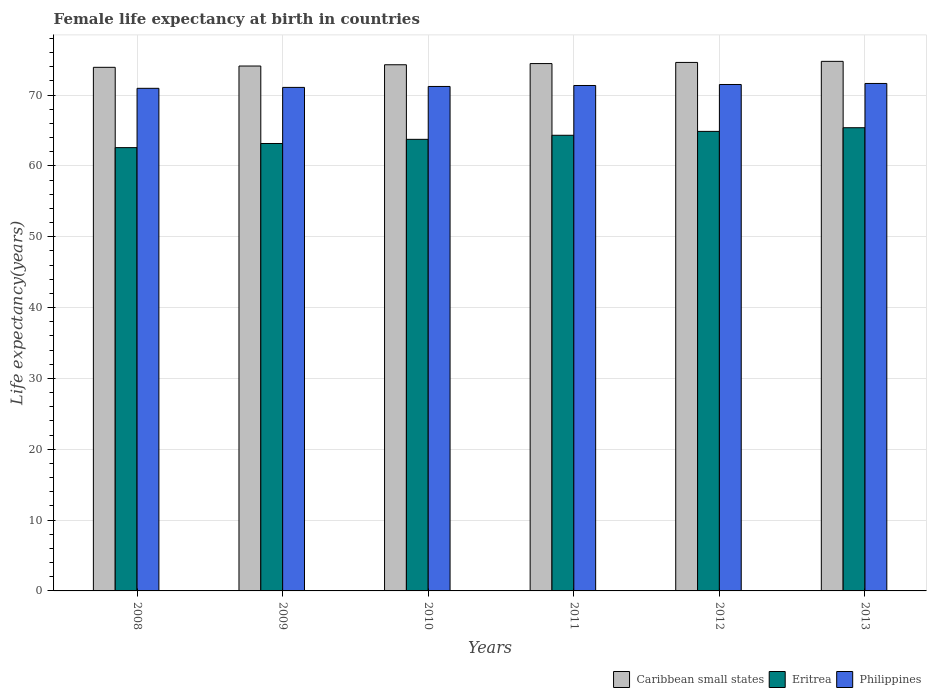How many groups of bars are there?
Your response must be concise. 6. Are the number of bars per tick equal to the number of legend labels?
Your response must be concise. Yes. What is the label of the 1st group of bars from the left?
Your answer should be very brief. 2008. In how many cases, is the number of bars for a given year not equal to the number of legend labels?
Offer a very short reply. 0. What is the female life expectancy at birth in Philippines in 2012?
Give a very brief answer. 71.49. Across all years, what is the maximum female life expectancy at birth in Eritrea?
Offer a very short reply. 65.39. Across all years, what is the minimum female life expectancy at birth in Eritrea?
Give a very brief answer. 62.58. In which year was the female life expectancy at birth in Caribbean small states maximum?
Provide a short and direct response. 2013. What is the total female life expectancy at birth in Philippines in the graph?
Ensure brevity in your answer.  427.72. What is the difference between the female life expectancy at birth in Philippines in 2010 and that in 2013?
Keep it short and to the point. -0.42. What is the difference between the female life expectancy at birth in Philippines in 2010 and the female life expectancy at birth in Eritrea in 2012?
Your response must be concise. 6.34. What is the average female life expectancy at birth in Philippines per year?
Make the answer very short. 71.29. In the year 2010, what is the difference between the female life expectancy at birth in Philippines and female life expectancy at birth in Caribbean small states?
Ensure brevity in your answer.  -3.06. What is the ratio of the female life expectancy at birth in Eritrea in 2012 to that in 2013?
Keep it short and to the point. 0.99. What is the difference between the highest and the second highest female life expectancy at birth in Caribbean small states?
Your answer should be compact. 0.15. What is the difference between the highest and the lowest female life expectancy at birth in Philippines?
Keep it short and to the point. 0.69. Is the sum of the female life expectancy at birth in Caribbean small states in 2009 and 2012 greater than the maximum female life expectancy at birth in Philippines across all years?
Make the answer very short. Yes. What does the 1st bar from the left in 2013 represents?
Provide a succinct answer. Caribbean small states. What does the 2nd bar from the right in 2012 represents?
Your answer should be very brief. Eritrea. What is the difference between two consecutive major ticks on the Y-axis?
Keep it short and to the point. 10. Does the graph contain any zero values?
Make the answer very short. No. Does the graph contain grids?
Your response must be concise. Yes. How many legend labels are there?
Give a very brief answer. 3. What is the title of the graph?
Give a very brief answer. Female life expectancy at birth in countries. Does "St. Vincent and the Grenadines" appear as one of the legend labels in the graph?
Your answer should be compact. No. What is the label or title of the Y-axis?
Offer a very short reply. Life expectancy(years). What is the Life expectancy(years) in Caribbean small states in 2008?
Provide a short and direct response. 73.91. What is the Life expectancy(years) in Eritrea in 2008?
Offer a terse response. 62.58. What is the Life expectancy(years) in Philippines in 2008?
Provide a short and direct response. 70.95. What is the Life expectancy(years) in Caribbean small states in 2009?
Ensure brevity in your answer.  74.1. What is the Life expectancy(years) in Eritrea in 2009?
Ensure brevity in your answer.  63.16. What is the Life expectancy(years) of Philippines in 2009?
Offer a very short reply. 71.08. What is the Life expectancy(years) in Caribbean small states in 2010?
Your answer should be compact. 74.28. What is the Life expectancy(years) of Eritrea in 2010?
Provide a short and direct response. 63.75. What is the Life expectancy(years) in Philippines in 2010?
Your response must be concise. 71.21. What is the Life expectancy(years) of Caribbean small states in 2011?
Make the answer very short. 74.44. What is the Life expectancy(years) of Eritrea in 2011?
Your response must be concise. 64.32. What is the Life expectancy(years) in Philippines in 2011?
Provide a succinct answer. 71.35. What is the Life expectancy(years) in Caribbean small states in 2012?
Keep it short and to the point. 74.6. What is the Life expectancy(years) in Eritrea in 2012?
Your answer should be very brief. 64.87. What is the Life expectancy(years) of Philippines in 2012?
Your answer should be compact. 71.49. What is the Life expectancy(years) in Caribbean small states in 2013?
Your answer should be compact. 74.76. What is the Life expectancy(years) of Eritrea in 2013?
Provide a succinct answer. 65.39. What is the Life expectancy(years) of Philippines in 2013?
Your answer should be very brief. 71.64. Across all years, what is the maximum Life expectancy(years) of Caribbean small states?
Your answer should be very brief. 74.76. Across all years, what is the maximum Life expectancy(years) of Eritrea?
Your answer should be compact. 65.39. Across all years, what is the maximum Life expectancy(years) in Philippines?
Ensure brevity in your answer.  71.64. Across all years, what is the minimum Life expectancy(years) in Caribbean small states?
Offer a very short reply. 73.91. Across all years, what is the minimum Life expectancy(years) in Eritrea?
Your answer should be compact. 62.58. Across all years, what is the minimum Life expectancy(years) of Philippines?
Keep it short and to the point. 70.95. What is the total Life expectancy(years) in Caribbean small states in the graph?
Offer a very short reply. 446.1. What is the total Life expectancy(years) of Eritrea in the graph?
Your answer should be compact. 384.07. What is the total Life expectancy(years) in Philippines in the graph?
Ensure brevity in your answer.  427.72. What is the difference between the Life expectancy(years) in Caribbean small states in 2008 and that in 2009?
Your response must be concise. -0.18. What is the difference between the Life expectancy(years) of Eritrea in 2008 and that in 2009?
Keep it short and to the point. -0.58. What is the difference between the Life expectancy(years) in Philippines in 2008 and that in 2009?
Your answer should be compact. -0.13. What is the difference between the Life expectancy(years) of Caribbean small states in 2008 and that in 2010?
Provide a short and direct response. -0.36. What is the difference between the Life expectancy(years) in Eritrea in 2008 and that in 2010?
Give a very brief answer. -1.17. What is the difference between the Life expectancy(years) in Philippines in 2008 and that in 2010?
Make the answer very short. -0.26. What is the difference between the Life expectancy(years) of Caribbean small states in 2008 and that in 2011?
Keep it short and to the point. -0.53. What is the difference between the Life expectancy(years) in Eritrea in 2008 and that in 2011?
Offer a terse response. -1.74. What is the difference between the Life expectancy(years) in Philippines in 2008 and that in 2011?
Ensure brevity in your answer.  -0.4. What is the difference between the Life expectancy(years) of Caribbean small states in 2008 and that in 2012?
Offer a very short reply. -0.69. What is the difference between the Life expectancy(years) in Eritrea in 2008 and that in 2012?
Keep it short and to the point. -2.29. What is the difference between the Life expectancy(years) of Philippines in 2008 and that in 2012?
Your answer should be very brief. -0.54. What is the difference between the Life expectancy(years) of Caribbean small states in 2008 and that in 2013?
Keep it short and to the point. -0.84. What is the difference between the Life expectancy(years) of Eritrea in 2008 and that in 2013?
Offer a very short reply. -2.81. What is the difference between the Life expectancy(years) in Philippines in 2008 and that in 2013?
Provide a short and direct response. -0.69. What is the difference between the Life expectancy(years) of Caribbean small states in 2009 and that in 2010?
Keep it short and to the point. -0.18. What is the difference between the Life expectancy(years) of Eritrea in 2009 and that in 2010?
Your answer should be very brief. -0.59. What is the difference between the Life expectancy(years) in Philippines in 2009 and that in 2010?
Ensure brevity in your answer.  -0.13. What is the difference between the Life expectancy(years) of Caribbean small states in 2009 and that in 2011?
Keep it short and to the point. -0.35. What is the difference between the Life expectancy(years) in Eritrea in 2009 and that in 2011?
Make the answer very short. -1.16. What is the difference between the Life expectancy(years) of Philippines in 2009 and that in 2011?
Your answer should be very brief. -0.27. What is the difference between the Life expectancy(years) in Caribbean small states in 2009 and that in 2012?
Provide a succinct answer. -0.51. What is the difference between the Life expectancy(years) of Eritrea in 2009 and that in 2012?
Offer a very short reply. -1.71. What is the difference between the Life expectancy(years) of Philippines in 2009 and that in 2012?
Your answer should be compact. -0.41. What is the difference between the Life expectancy(years) of Caribbean small states in 2009 and that in 2013?
Give a very brief answer. -0.66. What is the difference between the Life expectancy(years) in Eritrea in 2009 and that in 2013?
Keep it short and to the point. -2.23. What is the difference between the Life expectancy(years) in Philippines in 2009 and that in 2013?
Ensure brevity in your answer.  -0.56. What is the difference between the Life expectancy(years) in Caribbean small states in 2010 and that in 2011?
Your answer should be compact. -0.17. What is the difference between the Life expectancy(years) of Eritrea in 2010 and that in 2011?
Your response must be concise. -0.57. What is the difference between the Life expectancy(years) of Philippines in 2010 and that in 2011?
Provide a succinct answer. -0.14. What is the difference between the Life expectancy(years) of Caribbean small states in 2010 and that in 2012?
Offer a very short reply. -0.33. What is the difference between the Life expectancy(years) in Eritrea in 2010 and that in 2012?
Provide a short and direct response. -1.12. What is the difference between the Life expectancy(years) of Philippines in 2010 and that in 2012?
Your response must be concise. -0.28. What is the difference between the Life expectancy(years) in Caribbean small states in 2010 and that in 2013?
Give a very brief answer. -0.48. What is the difference between the Life expectancy(years) in Eritrea in 2010 and that in 2013?
Your answer should be very brief. -1.64. What is the difference between the Life expectancy(years) in Philippines in 2010 and that in 2013?
Keep it short and to the point. -0.42. What is the difference between the Life expectancy(years) in Caribbean small states in 2011 and that in 2012?
Ensure brevity in your answer.  -0.16. What is the difference between the Life expectancy(years) in Eritrea in 2011 and that in 2012?
Your response must be concise. -0.55. What is the difference between the Life expectancy(years) in Philippines in 2011 and that in 2012?
Provide a succinct answer. -0.14. What is the difference between the Life expectancy(years) of Caribbean small states in 2011 and that in 2013?
Provide a short and direct response. -0.31. What is the difference between the Life expectancy(years) in Eritrea in 2011 and that in 2013?
Your response must be concise. -1.07. What is the difference between the Life expectancy(years) of Philippines in 2011 and that in 2013?
Your answer should be compact. -0.29. What is the difference between the Life expectancy(years) in Caribbean small states in 2012 and that in 2013?
Offer a very short reply. -0.15. What is the difference between the Life expectancy(years) of Eritrea in 2012 and that in 2013?
Provide a short and direct response. -0.52. What is the difference between the Life expectancy(years) of Philippines in 2012 and that in 2013?
Ensure brevity in your answer.  -0.15. What is the difference between the Life expectancy(years) in Caribbean small states in 2008 and the Life expectancy(years) in Eritrea in 2009?
Make the answer very short. 10.75. What is the difference between the Life expectancy(years) of Caribbean small states in 2008 and the Life expectancy(years) of Philippines in 2009?
Offer a terse response. 2.83. What is the difference between the Life expectancy(years) in Eritrea in 2008 and the Life expectancy(years) in Philippines in 2009?
Offer a terse response. -8.5. What is the difference between the Life expectancy(years) in Caribbean small states in 2008 and the Life expectancy(years) in Eritrea in 2010?
Provide a succinct answer. 10.17. What is the difference between the Life expectancy(years) of Caribbean small states in 2008 and the Life expectancy(years) of Philippines in 2010?
Ensure brevity in your answer.  2.7. What is the difference between the Life expectancy(years) in Eritrea in 2008 and the Life expectancy(years) in Philippines in 2010?
Offer a very short reply. -8.64. What is the difference between the Life expectancy(years) of Caribbean small states in 2008 and the Life expectancy(years) of Eritrea in 2011?
Provide a succinct answer. 9.59. What is the difference between the Life expectancy(years) of Caribbean small states in 2008 and the Life expectancy(years) of Philippines in 2011?
Make the answer very short. 2.57. What is the difference between the Life expectancy(years) of Eritrea in 2008 and the Life expectancy(years) of Philippines in 2011?
Offer a terse response. -8.77. What is the difference between the Life expectancy(years) of Caribbean small states in 2008 and the Life expectancy(years) of Eritrea in 2012?
Provide a succinct answer. 9.04. What is the difference between the Life expectancy(years) of Caribbean small states in 2008 and the Life expectancy(years) of Philippines in 2012?
Provide a short and direct response. 2.42. What is the difference between the Life expectancy(years) of Eritrea in 2008 and the Life expectancy(years) of Philippines in 2012?
Keep it short and to the point. -8.91. What is the difference between the Life expectancy(years) of Caribbean small states in 2008 and the Life expectancy(years) of Eritrea in 2013?
Offer a very short reply. 8.53. What is the difference between the Life expectancy(years) in Caribbean small states in 2008 and the Life expectancy(years) in Philippines in 2013?
Ensure brevity in your answer.  2.28. What is the difference between the Life expectancy(years) of Eritrea in 2008 and the Life expectancy(years) of Philippines in 2013?
Your answer should be very brief. -9.06. What is the difference between the Life expectancy(years) in Caribbean small states in 2009 and the Life expectancy(years) in Eritrea in 2010?
Your response must be concise. 10.35. What is the difference between the Life expectancy(years) in Caribbean small states in 2009 and the Life expectancy(years) in Philippines in 2010?
Keep it short and to the point. 2.89. What is the difference between the Life expectancy(years) of Eritrea in 2009 and the Life expectancy(years) of Philippines in 2010?
Give a very brief answer. -8.05. What is the difference between the Life expectancy(years) in Caribbean small states in 2009 and the Life expectancy(years) in Eritrea in 2011?
Give a very brief answer. 9.78. What is the difference between the Life expectancy(years) of Caribbean small states in 2009 and the Life expectancy(years) of Philippines in 2011?
Your response must be concise. 2.75. What is the difference between the Life expectancy(years) in Eritrea in 2009 and the Life expectancy(years) in Philippines in 2011?
Your response must be concise. -8.19. What is the difference between the Life expectancy(years) of Caribbean small states in 2009 and the Life expectancy(years) of Eritrea in 2012?
Offer a terse response. 9.23. What is the difference between the Life expectancy(years) of Caribbean small states in 2009 and the Life expectancy(years) of Philippines in 2012?
Provide a short and direct response. 2.61. What is the difference between the Life expectancy(years) in Eritrea in 2009 and the Life expectancy(years) in Philippines in 2012?
Your answer should be compact. -8.33. What is the difference between the Life expectancy(years) of Caribbean small states in 2009 and the Life expectancy(years) of Eritrea in 2013?
Ensure brevity in your answer.  8.71. What is the difference between the Life expectancy(years) of Caribbean small states in 2009 and the Life expectancy(years) of Philippines in 2013?
Offer a very short reply. 2.46. What is the difference between the Life expectancy(years) of Eritrea in 2009 and the Life expectancy(years) of Philippines in 2013?
Provide a short and direct response. -8.47. What is the difference between the Life expectancy(years) in Caribbean small states in 2010 and the Life expectancy(years) in Eritrea in 2011?
Give a very brief answer. 9.95. What is the difference between the Life expectancy(years) of Caribbean small states in 2010 and the Life expectancy(years) of Philippines in 2011?
Offer a terse response. 2.93. What is the difference between the Life expectancy(years) in Caribbean small states in 2010 and the Life expectancy(years) in Eritrea in 2012?
Give a very brief answer. 9.4. What is the difference between the Life expectancy(years) in Caribbean small states in 2010 and the Life expectancy(years) in Philippines in 2012?
Your answer should be compact. 2.79. What is the difference between the Life expectancy(years) of Eritrea in 2010 and the Life expectancy(years) of Philippines in 2012?
Ensure brevity in your answer.  -7.74. What is the difference between the Life expectancy(years) of Caribbean small states in 2010 and the Life expectancy(years) of Eritrea in 2013?
Give a very brief answer. 8.89. What is the difference between the Life expectancy(years) in Caribbean small states in 2010 and the Life expectancy(years) in Philippines in 2013?
Offer a very short reply. 2.64. What is the difference between the Life expectancy(years) in Eritrea in 2010 and the Life expectancy(years) in Philippines in 2013?
Make the answer very short. -7.89. What is the difference between the Life expectancy(years) in Caribbean small states in 2011 and the Life expectancy(years) in Eritrea in 2012?
Offer a terse response. 9.57. What is the difference between the Life expectancy(years) of Caribbean small states in 2011 and the Life expectancy(years) of Philippines in 2012?
Your answer should be compact. 2.96. What is the difference between the Life expectancy(years) of Eritrea in 2011 and the Life expectancy(years) of Philippines in 2012?
Provide a succinct answer. -7.17. What is the difference between the Life expectancy(years) in Caribbean small states in 2011 and the Life expectancy(years) in Eritrea in 2013?
Offer a terse response. 9.06. What is the difference between the Life expectancy(years) in Caribbean small states in 2011 and the Life expectancy(years) in Philippines in 2013?
Provide a succinct answer. 2.81. What is the difference between the Life expectancy(years) of Eritrea in 2011 and the Life expectancy(years) of Philippines in 2013?
Offer a very short reply. -7.31. What is the difference between the Life expectancy(years) of Caribbean small states in 2012 and the Life expectancy(years) of Eritrea in 2013?
Make the answer very short. 9.22. What is the difference between the Life expectancy(years) in Caribbean small states in 2012 and the Life expectancy(years) in Philippines in 2013?
Provide a short and direct response. 2.97. What is the difference between the Life expectancy(years) of Eritrea in 2012 and the Life expectancy(years) of Philippines in 2013?
Your answer should be compact. -6.76. What is the average Life expectancy(years) in Caribbean small states per year?
Offer a very short reply. 74.35. What is the average Life expectancy(years) in Eritrea per year?
Your answer should be compact. 64.01. What is the average Life expectancy(years) of Philippines per year?
Offer a very short reply. 71.29. In the year 2008, what is the difference between the Life expectancy(years) in Caribbean small states and Life expectancy(years) in Eritrea?
Keep it short and to the point. 11.34. In the year 2008, what is the difference between the Life expectancy(years) of Caribbean small states and Life expectancy(years) of Philippines?
Your response must be concise. 2.96. In the year 2008, what is the difference between the Life expectancy(years) of Eritrea and Life expectancy(years) of Philippines?
Make the answer very short. -8.37. In the year 2009, what is the difference between the Life expectancy(years) of Caribbean small states and Life expectancy(years) of Eritrea?
Offer a terse response. 10.94. In the year 2009, what is the difference between the Life expectancy(years) of Caribbean small states and Life expectancy(years) of Philippines?
Provide a short and direct response. 3.02. In the year 2009, what is the difference between the Life expectancy(years) in Eritrea and Life expectancy(years) in Philippines?
Provide a succinct answer. -7.92. In the year 2010, what is the difference between the Life expectancy(years) in Caribbean small states and Life expectancy(years) in Eritrea?
Your response must be concise. 10.53. In the year 2010, what is the difference between the Life expectancy(years) of Caribbean small states and Life expectancy(years) of Philippines?
Ensure brevity in your answer.  3.06. In the year 2010, what is the difference between the Life expectancy(years) in Eritrea and Life expectancy(years) in Philippines?
Provide a succinct answer. -7.46. In the year 2011, what is the difference between the Life expectancy(years) of Caribbean small states and Life expectancy(years) of Eritrea?
Offer a terse response. 10.12. In the year 2011, what is the difference between the Life expectancy(years) in Caribbean small states and Life expectancy(years) in Philippines?
Your response must be concise. 3.1. In the year 2011, what is the difference between the Life expectancy(years) in Eritrea and Life expectancy(years) in Philippines?
Offer a terse response. -7.03. In the year 2012, what is the difference between the Life expectancy(years) of Caribbean small states and Life expectancy(years) of Eritrea?
Ensure brevity in your answer.  9.73. In the year 2012, what is the difference between the Life expectancy(years) of Caribbean small states and Life expectancy(years) of Philippines?
Give a very brief answer. 3.11. In the year 2012, what is the difference between the Life expectancy(years) of Eritrea and Life expectancy(years) of Philippines?
Provide a succinct answer. -6.62. In the year 2013, what is the difference between the Life expectancy(years) in Caribbean small states and Life expectancy(years) in Eritrea?
Give a very brief answer. 9.37. In the year 2013, what is the difference between the Life expectancy(years) in Caribbean small states and Life expectancy(years) in Philippines?
Offer a very short reply. 3.12. In the year 2013, what is the difference between the Life expectancy(years) of Eritrea and Life expectancy(years) of Philippines?
Make the answer very short. -6.25. What is the ratio of the Life expectancy(years) in Eritrea in 2008 to that in 2009?
Your answer should be compact. 0.99. What is the ratio of the Life expectancy(years) of Philippines in 2008 to that in 2009?
Keep it short and to the point. 1. What is the ratio of the Life expectancy(years) of Eritrea in 2008 to that in 2010?
Your response must be concise. 0.98. What is the ratio of the Life expectancy(years) in Caribbean small states in 2008 to that in 2011?
Provide a succinct answer. 0.99. What is the ratio of the Life expectancy(years) of Eritrea in 2008 to that in 2011?
Ensure brevity in your answer.  0.97. What is the ratio of the Life expectancy(years) of Philippines in 2008 to that in 2011?
Your answer should be compact. 0.99. What is the ratio of the Life expectancy(years) in Caribbean small states in 2008 to that in 2012?
Keep it short and to the point. 0.99. What is the ratio of the Life expectancy(years) in Eritrea in 2008 to that in 2012?
Offer a terse response. 0.96. What is the ratio of the Life expectancy(years) of Caribbean small states in 2008 to that in 2013?
Offer a very short reply. 0.99. What is the ratio of the Life expectancy(years) of Eritrea in 2008 to that in 2013?
Offer a terse response. 0.96. What is the ratio of the Life expectancy(years) of Philippines in 2008 to that in 2013?
Provide a succinct answer. 0.99. What is the ratio of the Life expectancy(years) of Eritrea in 2009 to that in 2010?
Your response must be concise. 0.99. What is the ratio of the Life expectancy(years) in Philippines in 2009 to that in 2010?
Your answer should be compact. 1. What is the ratio of the Life expectancy(years) of Caribbean small states in 2009 to that in 2011?
Your response must be concise. 1. What is the ratio of the Life expectancy(years) of Philippines in 2009 to that in 2011?
Provide a succinct answer. 1. What is the ratio of the Life expectancy(years) of Caribbean small states in 2009 to that in 2012?
Offer a terse response. 0.99. What is the ratio of the Life expectancy(years) in Eritrea in 2009 to that in 2012?
Offer a very short reply. 0.97. What is the ratio of the Life expectancy(years) in Philippines in 2009 to that in 2012?
Your answer should be compact. 0.99. What is the ratio of the Life expectancy(years) in Caribbean small states in 2009 to that in 2013?
Keep it short and to the point. 0.99. What is the ratio of the Life expectancy(years) of Philippines in 2009 to that in 2013?
Your answer should be compact. 0.99. What is the ratio of the Life expectancy(years) in Philippines in 2010 to that in 2011?
Give a very brief answer. 1. What is the ratio of the Life expectancy(years) of Eritrea in 2010 to that in 2012?
Offer a terse response. 0.98. What is the ratio of the Life expectancy(years) in Philippines in 2010 to that in 2012?
Offer a terse response. 1. What is the ratio of the Life expectancy(years) in Caribbean small states in 2010 to that in 2013?
Make the answer very short. 0.99. What is the ratio of the Life expectancy(years) in Eritrea in 2010 to that in 2013?
Give a very brief answer. 0.97. What is the ratio of the Life expectancy(years) in Eritrea in 2011 to that in 2012?
Make the answer very short. 0.99. What is the ratio of the Life expectancy(years) of Caribbean small states in 2011 to that in 2013?
Ensure brevity in your answer.  1. What is the ratio of the Life expectancy(years) of Eritrea in 2011 to that in 2013?
Your answer should be very brief. 0.98. What is the ratio of the Life expectancy(years) of Philippines in 2011 to that in 2013?
Give a very brief answer. 1. What is the difference between the highest and the second highest Life expectancy(years) of Caribbean small states?
Provide a short and direct response. 0.15. What is the difference between the highest and the second highest Life expectancy(years) in Eritrea?
Your response must be concise. 0.52. What is the difference between the highest and the second highest Life expectancy(years) of Philippines?
Offer a very short reply. 0.15. What is the difference between the highest and the lowest Life expectancy(years) in Caribbean small states?
Offer a very short reply. 0.84. What is the difference between the highest and the lowest Life expectancy(years) of Eritrea?
Your response must be concise. 2.81. What is the difference between the highest and the lowest Life expectancy(years) of Philippines?
Your answer should be compact. 0.69. 